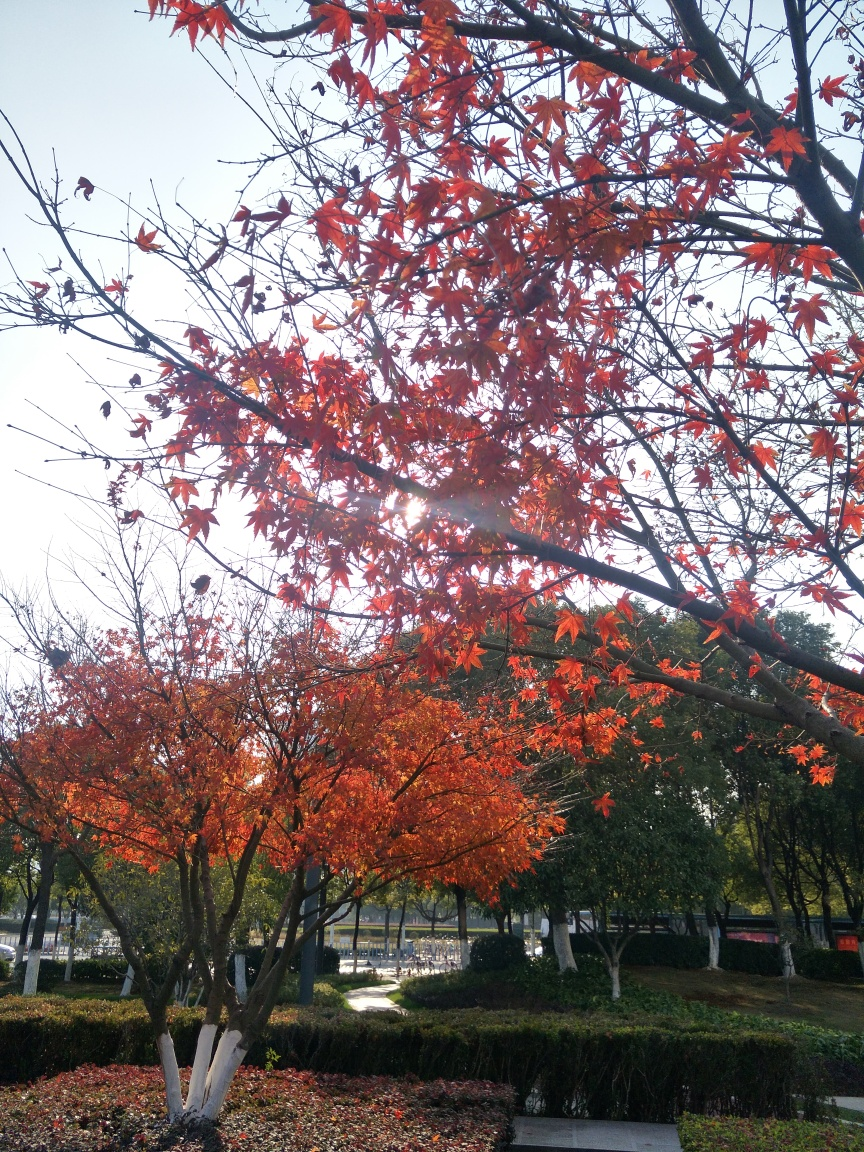Is there any sign of human activity in the image? There are no direct signs of human activity, such as people or vehicles, present in the image. However, the well-maintained grass and the neat appearance of the trees indicate that this is a cared-for park or garden, suggesting an indirect human presence. 